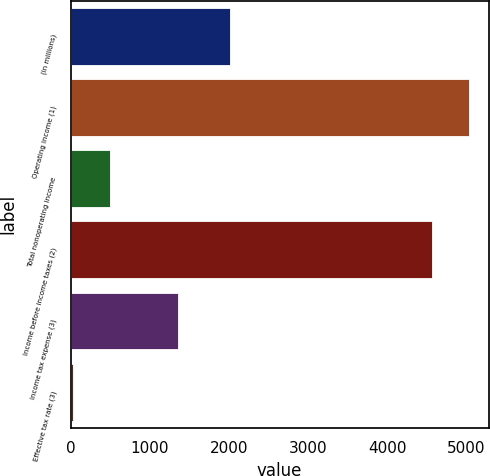Convert chart to OTSL. <chart><loc_0><loc_0><loc_500><loc_500><bar_chart><fcel>(in millions)<fcel>Operating income (1)<fcel>Total nonoperating income<fcel>Income before income taxes (2)<fcel>Income tax expense (3)<fcel>Effective tax rate (3)<nl><fcel>2016<fcel>5030.44<fcel>494.04<fcel>4566<fcel>1352<fcel>29.6<nl></chart> 